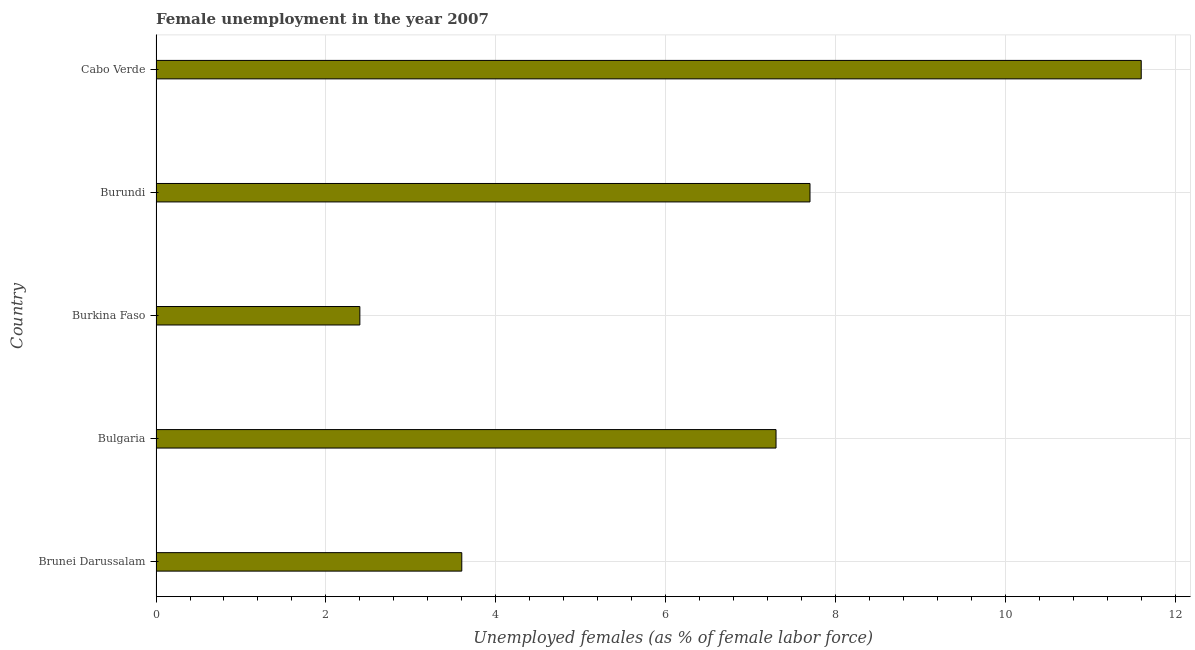Does the graph contain any zero values?
Your answer should be very brief. No. Does the graph contain grids?
Offer a very short reply. Yes. What is the title of the graph?
Provide a short and direct response. Female unemployment in the year 2007. What is the label or title of the X-axis?
Your answer should be compact. Unemployed females (as % of female labor force). What is the label or title of the Y-axis?
Your response must be concise. Country. What is the unemployed females population in Brunei Darussalam?
Offer a terse response. 3.6. Across all countries, what is the maximum unemployed females population?
Your answer should be very brief. 11.6. Across all countries, what is the minimum unemployed females population?
Keep it short and to the point. 2.4. In which country was the unemployed females population maximum?
Your answer should be compact. Cabo Verde. In which country was the unemployed females population minimum?
Offer a terse response. Burkina Faso. What is the sum of the unemployed females population?
Keep it short and to the point. 32.6. What is the average unemployed females population per country?
Make the answer very short. 6.52. What is the median unemployed females population?
Provide a succinct answer. 7.3. What is the ratio of the unemployed females population in Burkina Faso to that in Burundi?
Offer a terse response. 0.31. Is the unemployed females population in Bulgaria less than that in Cabo Verde?
Make the answer very short. Yes. What is the difference between the highest and the second highest unemployed females population?
Offer a very short reply. 3.9. Is the sum of the unemployed females population in Bulgaria and Cabo Verde greater than the maximum unemployed females population across all countries?
Your answer should be very brief. Yes. Are all the bars in the graph horizontal?
Provide a succinct answer. Yes. What is the difference between two consecutive major ticks on the X-axis?
Offer a very short reply. 2. What is the Unemployed females (as % of female labor force) of Brunei Darussalam?
Provide a short and direct response. 3.6. What is the Unemployed females (as % of female labor force) in Bulgaria?
Your answer should be very brief. 7.3. What is the Unemployed females (as % of female labor force) of Burkina Faso?
Make the answer very short. 2.4. What is the Unemployed females (as % of female labor force) in Burundi?
Keep it short and to the point. 7.7. What is the Unemployed females (as % of female labor force) of Cabo Verde?
Provide a short and direct response. 11.6. What is the difference between the Unemployed females (as % of female labor force) in Brunei Darussalam and Burkina Faso?
Offer a terse response. 1.2. What is the difference between the Unemployed females (as % of female labor force) in Bulgaria and Burundi?
Give a very brief answer. -0.4. What is the difference between the Unemployed females (as % of female labor force) in Burkina Faso and Burundi?
Your answer should be compact. -5.3. What is the difference between the Unemployed females (as % of female labor force) in Burkina Faso and Cabo Verde?
Your answer should be compact. -9.2. What is the ratio of the Unemployed females (as % of female labor force) in Brunei Darussalam to that in Bulgaria?
Your answer should be compact. 0.49. What is the ratio of the Unemployed females (as % of female labor force) in Brunei Darussalam to that in Burundi?
Your answer should be compact. 0.47. What is the ratio of the Unemployed females (as % of female labor force) in Brunei Darussalam to that in Cabo Verde?
Your answer should be compact. 0.31. What is the ratio of the Unemployed females (as % of female labor force) in Bulgaria to that in Burkina Faso?
Your response must be concise. 3.04. What is the ratio of the Unemployed females (as % of female labor force) in Bulgaria to that in Burundi?
Ensure brevity in your answer.  0.95. What is the ratio of the Unemployed females (as % of female labor force) in Bulgaria to that in Cabo Verde?
Ensure brevity in your answer.  0.63. What is the ratio of the Unemployed females (as % of female labor force) in Burkina Faso to that in Burundi?
Your answer should be very brief. 0.31. What is the ratio of the Unemployed females (as % of female labor force) in Burkina Faso to that in Cabo Verde?
Give a very brief answer. 0.21. What is the ratio of the Unemployed females (as % of female labor force) in Burundi to that in Cabo Verde?
Ensure brevity in your answer.  0.66. 